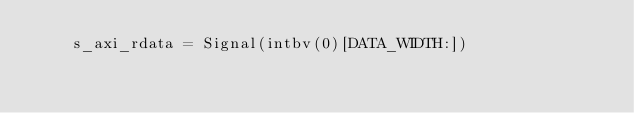Convert code to text. <code><loc_0><loc_0><loc_500><loc_500><_Python_>    s_axi_rdata = Signal(intbv(0)[DATA_WIDTH:])</code> 